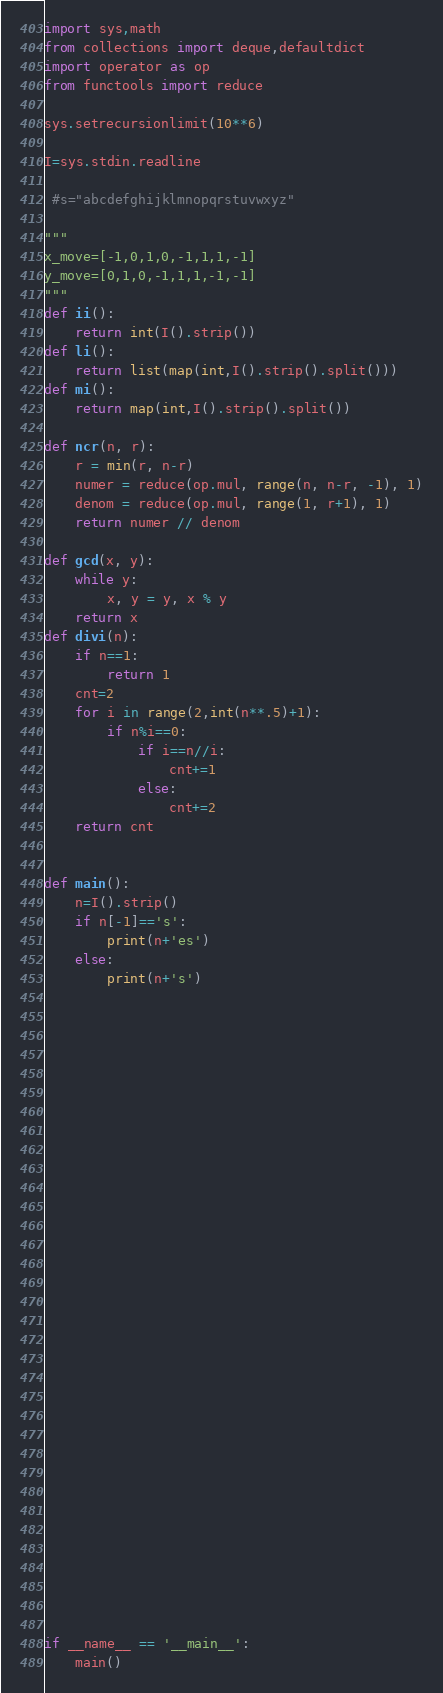Convert code to text. <code><loc_0><loc_0><loc_500><loc_500><_Python_>import sys,math
from collections import deque,defaultdict
import operator as op
from functools import reduce

sys.setrecursionlimit(10**6) 

I=sys.stdin.readline

 #s="abcdefghijklmnopqrstuvwxyz"

"""
x_move=[-1,0,1,0,-1,1,1,-1]
y_move=[0,1,0,-1,1,1,-1,-1]
"""
def ii():
	return int(I().strip())
def li():
	return list(map(int,I().strip().split()))
def mi():
	return map(int,I().strip().split())

def ncr(n, r):
    r = min(r, n-r)
    numer = reduce(op.mul, range(n, n-r, -1), 1)
    denom = reduce(op.mul, range(1, r+1), 1)
    return numer // denom

def gcd(x, y):
    while y:
        x, y = y, x % y
    return x
def divi(n):
	if n==1:
		return 1
	cnt=2
	for i in range(2,int(n**.5)+1):
		if n%i==0:
			if i==n//i:
				cnt+=1
			else:
				cnt+=2
	return cnt


def main():
	n=I().strip()
	if n[-1]=='s':
		print(n+'es')
	else:
		print(n+'s')
	

























	
	
	





if __name__ == '__main__':
	main()</code> 